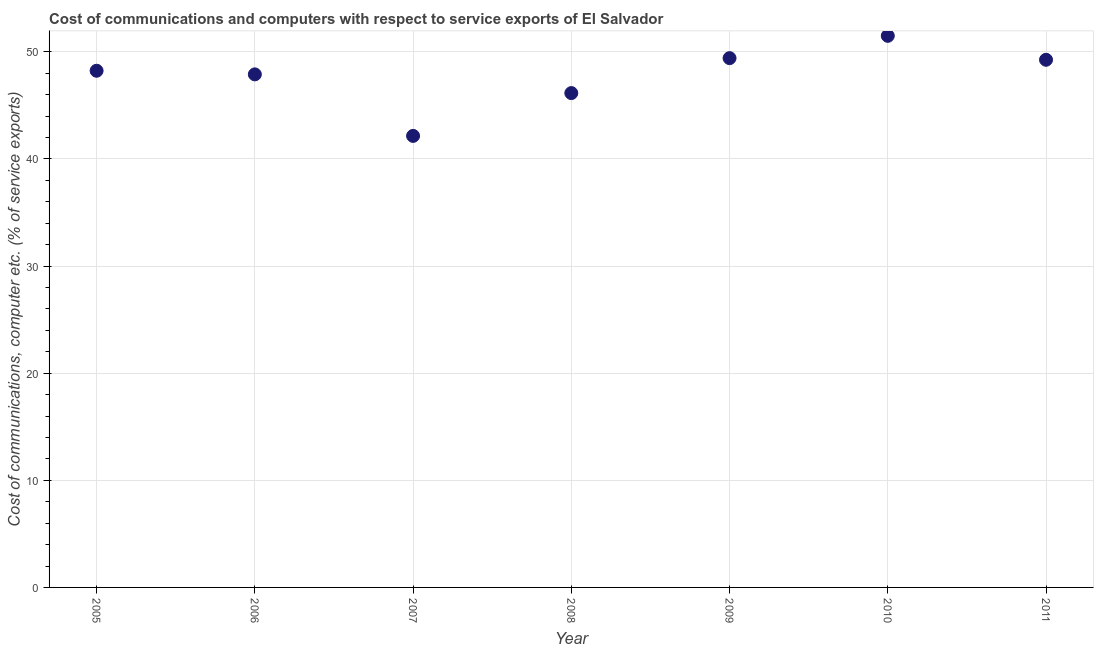What is the cost of communications and computer in 2005?
Provide a succinct answer. 48.23. Across all years, what is the maximum cost of communications and computer?
Keep it short and to the point. 51.49. Across all years, what is the minimum cost of communications and computer?
Provide a short and direct response. 42.15. In which year was the cost of communications and computer maximum?
Your answer should be compact. 2010. What is the sum of the cost of communications and computer?
Keep it short and to the point. 334.59. What is the difference between the cost of communications and computer in 2006 and 2011?
Provide a succinct answer. -1.36. What is the average cost of communications and computer per year?
Your answer should be very brief. 47.8. What is the median cost of communications and computer?
Make the answer very short. 48.23. In how many years, is the cost of communications and computer greater than 40 %?
Ensure brevity in your answer.  7. What is the ratio of the cost of communications and computer in 2007 to that in 2011?
Provide a succinct answer. 0.86. What is the difference between the highest and the second highest cost of communications and computer?
Offer a very short reply. 2.08. What is the difference between the highest and the lowest cost of communications and computer?
Provide a succinct answer. 9.34. Does the cost of communications and computer monotonically increase over the years?
Give a very brief answer. No. How many dotlines are there?
Your answer should be very brief. 1. What is the difference between two consecutive major ticks on the Y-axis?
Your answer should be very brief. 10. Are the values on the major ticks of Y-axis written in scientific E-notation?
Offer a very short reply. No. Does the graph contain any zero values?
Ensure brevity in your answer.  No. Does the graph contain grids?
Ensure brevity in your answer.  Yes. What is the title of the graph?
Provide a succinct answer. Cost of communications and computers with respect to service exports of El Salvador. What is the label or title of the X-axis?
Ensure brevity in your answer.  Year. What is the label or title of the Y-axis?
Your answer should be very brief. Cost of communications, computer etc. (% of service exports). What is the Cost of communications, computer etc. (% of service exports) in 2005?
Give a very brief answer. 48.23. What is the Cost of communications, computer etc. (% of service exports) in 2006?
Provide a succinct answer. 47.89. What is the Cost of communications, computer etc. (% of service exports) in 2007?
Make the answer very short. 42.15. What is the Cost of communications, computer etc. (% of service exports) in 2008?
Your answer should be very brief. 46.15. What is the Cost of communications, computer etc. (% of service exports) in 2009?
Provide a succinct answer. 49.41. What is the Cost of communications, computer etc. (% of service exports) in 2010?
Your response must be concise. 51.49. What is the Cost of communications, computer etc. (% of service exports) in 2011?
Offer a terse response. 49.26. What is the difference between the Cost of communications, computer etc. (% of service exports) in 2005 and 2006?
Your answer should be compact. 0.34. What is the difference between the Cost of communications, computer etc. (% of service exports) in 2005 and 2007?
Your answer should be very brief. 6.08. What is the difference between the Cost of communications, computer etc. (% of service exports) in 2005 and 2008?
Make the answer very short. 2.09. What is the difference between the Cost of communications, computer etc. (% of service exports) in 2005 and 2009?
Ensure brevity in your answer.  -1.18. What is the difference between the Cost of communications, computer etc. (% of service exports) in 2005 and 2010?
Make the answer very short. -3.26. What is the difference between the Cost of communications, computer etc. (% of service exports) in 2005 and 2011?
Offer a very short reply. -1.02. What is the difference between the Cost of communications, computer etc. (% of service exports) in 2006 and 2007?
Your answer should be very brief. 5.74. What is the difference between the Cost of communications, computer etc. (% of service exports) in 2006 and 2008?
Offer a terse response. 1.75. What is the difference between the Cost of communications, computer etc. (% of service exports) in 2006 and 2009?
Ensure brevity in your answer.  -1.52. What is the difference between the Cost of communications, computer etc. (% of service exports) in 2006 and 2010?
Your response must be concise. -3.6. What is the difference between the Cost of communications, computer etc. (% of service exports) in 2006 and 2011?
Provide a succinct answer. -1.36. What is the difference between the Cost of communications, computer etc. (% of service exports) in 2007 and 2008?
Offer a very short reply. -4. What is the difference between the Cost of communications, computer etc. (% of service exports) in 2007 and 2009?
Your response must be concise. -7.26. What is the difference between the Cost of communications, computer etc. (% of service exports) in 2007 and 2010?
Offer a terse response. -9.34. What is the difference between the Cost of communications, computer etc. (% of service exports) in 2007 and 2011?
Your response must be concise. -7.11. What is the difference between the Cost of communications, computer etc. (% of service exports) in 2008 and 2009?
Provide a succinct answer. -3.26. What is the difference between the Cost of communications, computer etc. (% of service exports) in 2008 and 2010?
Provide a succinct answer. -5.35. What is the difference between the Cost of communications, computer etc. (% of service exports) in 2008 and 2011?
Provide a short and direct response. -3.11. What is the difference between the Cost of communications, computer etc. (% of service exports) in 2009 and 2010?
Your answer should be compact. -2.08. What is the difference between the Cost of communications, computer etc. (% of service exports) in 2009 and 2011?
Make the answer very short. 0.15. What is the difference between the Cost of communications, computer etc. (% of service exports) in 2010 and 2011?
Your answer should be very brief. 2.24. What is the ratio of the Cost of communications, computer etc. (% of service exports) in 2005 to that in 2006?
Keep it short and to the point. 1.01. What is the ratio of the Cost of communications, computer etc. (% of service exports) in 2005 to that in 2007?
Ensure brevity in your answer.  1.14. What is the ratio of the Cost of communications, computer etc. (% of service exports) in 2005 to that in 2008?
Provide a succinct answer. 1.04. What is the ratio of the Cost of communications, computer etc. (% of service exports) in 2005 to that in 2009?
Give a very brief answer. 0.98. What is the ratio of the Cost of communications, computer etc. (% of service exports) in 2005 to that in 2010?
Ensure brevity in your answer.  0.94. What is the ratio of the Cost of communications, computer etc. (% of service exports) in 2005 to that in 2011?
Give a very brief answer. 0.98. What is the ratio of the Cost of communications, computer etc. (% of service exports) in 2006 to that in 2007?
Ensure brevity in your answer.  1.14. What is the ratio of the Cost of communications, computer etc. (% of service exports) in 2006 to that in 2008?
Give a very brief answer. 1.04. What is the ratio of the Cost of communications, computer etc. (% of service exports) in 2006 to that in 2009?
Make the answer very short. 0.97. What is the ratio of the Cost of communications, computer etc. (% of service exports) in 2006 to that in 2010?
Offer a very short reply. 0.93. What is the ratio of the Cost of communications, computer etc. (% of service exports) in 2006 to that in 2011?
Provide a succinct answer. 0.97. What is the ratio of the Cost of communications, computer etc. (% of service exports) in 2007 to that in 2008?
Your answer should be compact. 0.91. What is the ratio of the Cost of communications, computer etc. (% of service exports) in 2007 to that in 2009?
Provide a short and direct response. 0.85. What is the ratio of the Cost of communications, computer etc. (% of service exports) in 2007 to that in 2010?
Your response must be concise. 0.82. What is the ratio of the Cost of communications, computer etc. (% of service exports) in 2007 to that in 2011?
Your response must be concise. 0.86. What is the ratio of the Cost of communications, computer etc. (% of service exports) in 2008 to that in 2009?
Your answer should be very brief. 0.93. What is the ratio of the Cost of communications, computer etc. (% of service exports) in 2008 to that in 2010?
Keep it short and to the point. 0.9. What is the ratio of the Cost of communications, computer etc. (% of service exports) in 2008 to that in 2011?
Your answer should be very brief. 0.94. What is the ratio of the Cost of communications, computer etc. (% of service exports) in 2009 to that in 2011?
Keep it short and to the point. 1. What is the ratio of the Cost of communications, computer etc. (% of service exports) in 2010 to that in 2011?
Give a very brief answer. 1.04. 